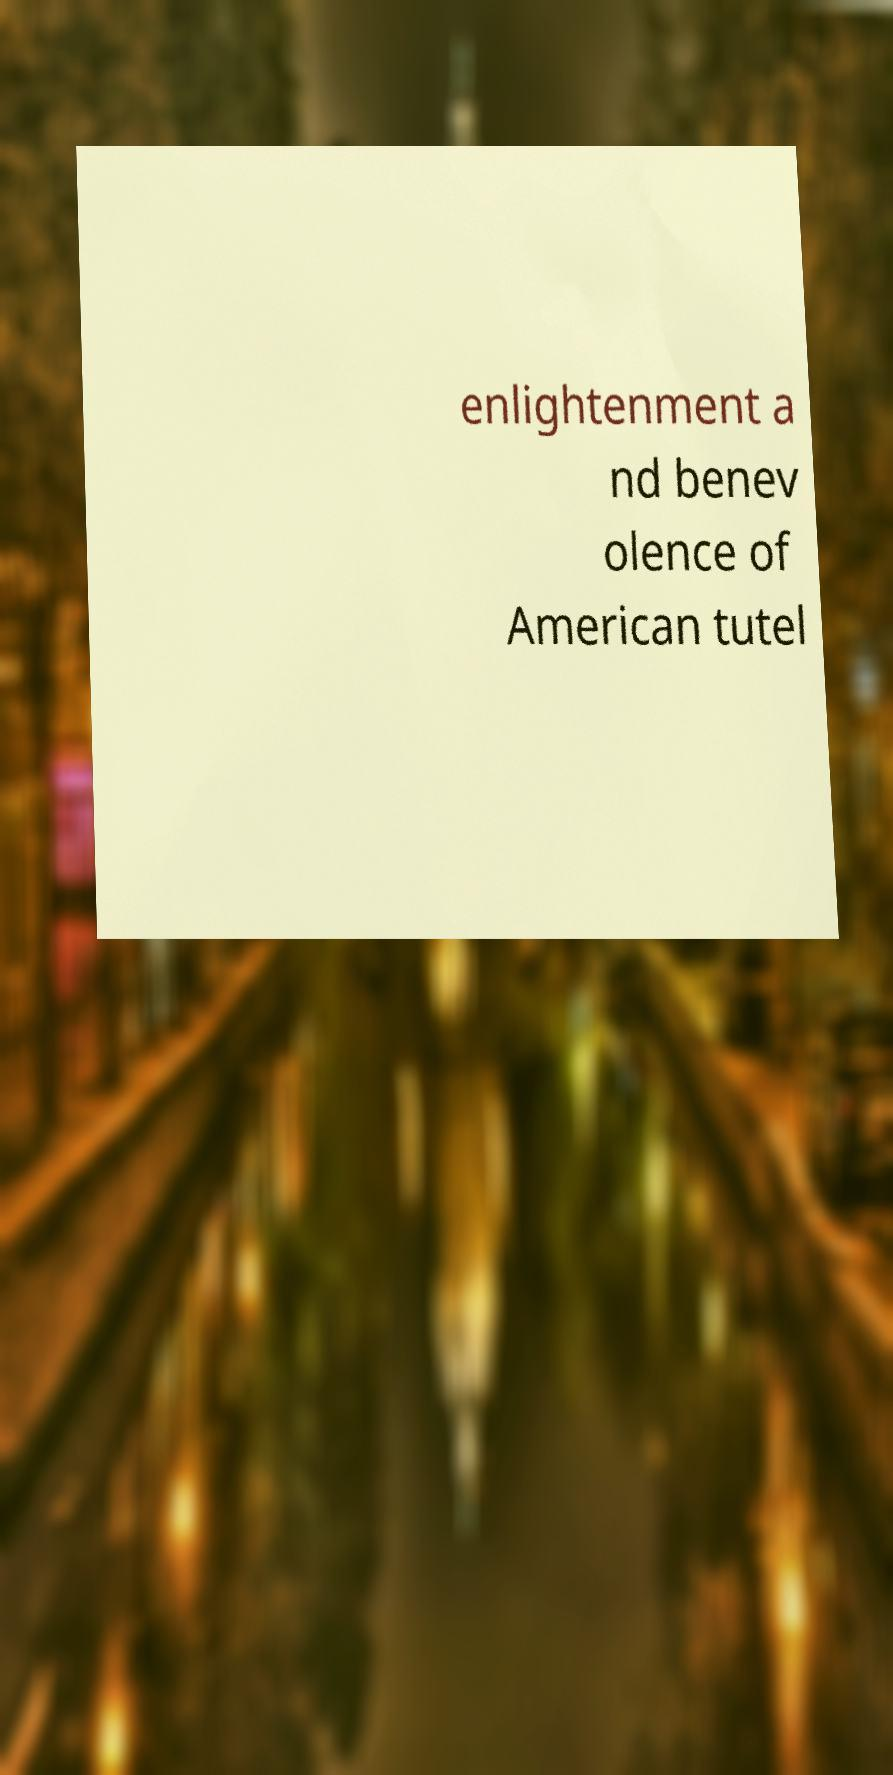Could you extract and type out the text from this image? enlightenment a nd benev olence of American tutel 